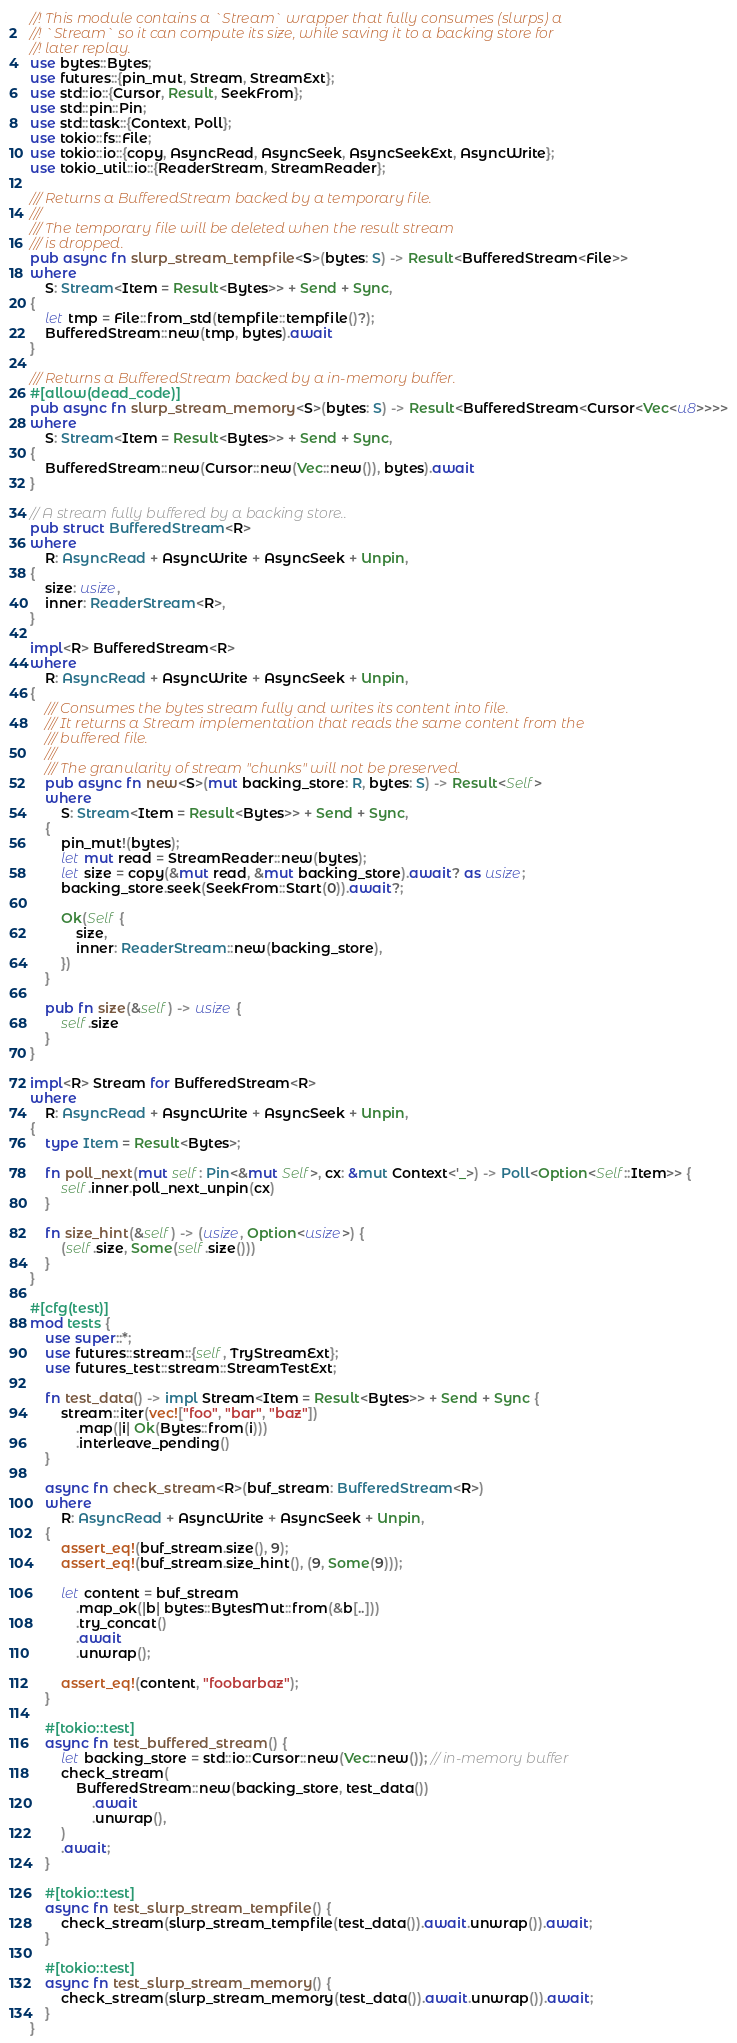<code> <loc_0><loc_0><loc_500><loc_500><_Rust_>//! This module contains a `Stream` wrapper that fully consumes (slurps) a
//! `Stream` so it can compute its size, while saving it to a backing store for
//! later replay.
use bytes::Bytes;
use futures::{pin_mut, Stream, StreamExt};
use std::io::{Cursor, Result, SeekFrom};
use std::pin::Pin;
use std::task::{Context, Poll};
use tokio::fs::File;
use tokio::io::{copy, AsyncRead, AsyncSeek, AsyncSeekExt, AsyncWrite};
use tokio_util::io::{ReaderStream, StreamReader};

/// Returns a BufferedStream backed by a temporary file.
///
/// The temporary file will be deleted when the result stream
/// is dropped.
pub async fn slurp_stream_tempfile<S>(bytes: S) -> Result<BufferedStream<File>>
where
    S: Stream<Item = Result<Bytes>> + Send + Sync,
{
    let tmp = File::from_std(tempfile::tempfile()?);
    BufferedStream::new(tmp, bytes).await
}

/// Returns a BufferedStream backed by a in-memory buffer.
#[allow(dead_code)]
pub async fn slurp_stream_memory<S>(bytes: S) -> Result<BufferedStream<Cursor<Vec<u8>>>>
where
    S: Stream<Item = Result<Bytes>> + Send + Sync,
{
    BufferedStream::new(Cursor::new(Vec::new()), bytes).await
}

// A stream fully buffered by a backing store..
pub struct BufferedStream<R>
where
    R: AsyncRead + AsyncWrite + AsyncSeek + Unpin,
{
    size: usize,
    inner: ReaderStream<R>,
}

impl<R> BufferedStream<R>
where
    R: AsyncRead + AsyncWrite + AsyncSeek + Unpin,
{
    /// Consumes the bytes stream fully and writes its content into file.
    /// It returns a Stream implementation that reads the same content from the
    /// buffered file.
    ///
    /// The granularity of stream "chunks" will not be preserved.
    pub async fn new<S>(mut backing_store: R, bytes: S) -> Result<Self>
    where
        S: Stream<Item = Result<Bytes>> + Send + Sync,
    {
        pin_mut!(bytes);
        let mut read = StreamReader::new(bytes);
        let size = copy(&mut read, &mut backing_store).await? as usize;
        backing_store.seek(SeekFrom::Start(0)).await?;

        Ok(Self {
            size,
            inner: ReaderStream::new(backing_store),
        })
    }

    pub fn size(&self) -> usize {
        self.size
    }
}

impl<R> Stream for BufferedStream<R>
where
    R: AsyncRead + AsyncWrite + AsyncSeek + Unpin,
{
    type Item = Result<Bytes>;

    fn poll_next(mut self: Pin<&mut Self>, cx: &mut Context<'_>) -> Poll<Option<Self::Item>> {
        self.inner.poll_next_unpin(cx)
    }

    fn size_hint(&self) -> (usize, Option<usize>) {
        (self.size, Some(self.size()))
    }
}

#[cfg(test)]
mod tests {
    use super::*;
    use futures::stream::{self, TryStreamExt};
    use futures_test::stream::StreamTestExt;

    fn test_data() -> impl Stream<Item = Result<Bytes>> + Send + Sync {
        stream::iter(vec!["foo", "bar", "baz"])
            .map(|i| Ok(Bytes::from(i)))
            .interleave_pending()
    }

    async fn check_stream<R>(buf_stream: BufferedStream<R>)
    where
        R: AsyncRead + AsyncWrite + AsyncSeek + Unpin,
    {
        assert_eq!(buf_stream.size(), 9);
        assert_eq!(buf_stream.size_hint(), (9, Some(9)));

        let content = buf_stream
            .map_ok(|b| bytes::BytesMut::from(&b[..]))
            .try_concat()
            .await
            .unwrap();

        assert_eq!(content, "foobarbaz");
    }

    #[tokio::test]
    async fn test_buffered_stream() {
        let backing_store = std::io::Cursor::new(Vec::new()); // in-memory buffer
        check_stream(
            BufferedStream::new(backing_store, test_data())
                .await
                .unwrap(),
        )
        .await;
    }

    #[tokio::test]
    async fn test_slurp_stream_tempfile() {
        check_stream(slurp_stream_tempfile(test_data()).await.unwrap()).await;
    }

    #[tokio::test]
    async fn test_slurp_stream_memory() {
        check_stream(slurp_stream_memory(test_data()).await.unwrap()).await;
    }
}
</code> 